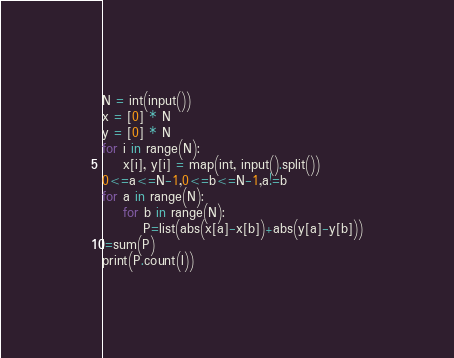Convert code to text. <code><loc_0><loc_0><loc_500><loc_500><_Python_>N = int(input())
x = [0] * N
y = [0] * N
for i in range(N):
    x[i], y[i] = map(int, input().split())
0<=a<=N-1,0<=b<=N-1,a!=b
for a in range(N):
    for b in range(N):
        P=list(abs(x[a]-x[b])+abs(y[a]-y[b]))
l=sum(P)
print(P.count(l))</code> 